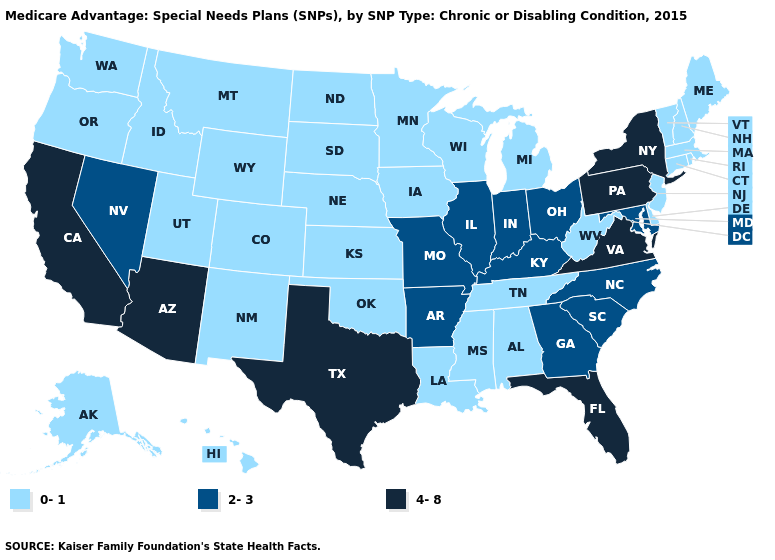What is the highest value in the USA?
Be succinct. 4-8. What is the value of Connecticut?
Keep it brief. 0-1. Name the states that have a value in the range 0-1?
Write a very short answer. Alaska, Alabama, Colorado, Connecticut, Delaware, Hawaii, Iowa, Idaho, Kansas, Louisiana, Massachusetts, Maine, Michigan, Minnesota, Mississippi, Montana, North Dakota, Nebraska, New Hampshire, New Jersey, New Mexico, Oklahoma, Oregon, Rhode Island, South Dakota, Tennessee, Utah, Vermont, Washington, Wisconsin, West Virginia, Wyoming. Name the states that have a value in the range 2-3?
Answer briefly. Arkansas, Georgia, Illinois, Indiana, Kentucky, Maryland, Missouri, North Carolina, Nevada, Ohio, South Carolina. What is the value of Nevada?
Keep it brief. 2-3. What is the value of Nevada?
Concise answer only. 2-3. Does New Hampshire have the highest value in the Northeast?
Give a very brief answer. No. Name the states that have a value in the range 4-8?
Short answer required. Arizona, California, Florida, New York, Pennsylvania, Texas, Virginia. Does Idaho have the same value as Wisconsin?
Keep it brief. Yes. Name the states that have a value in the range 0-1?
Keep it brief. Alaska, Alabama, Colorado, Connecticut, Delaware, Hawaii, Iowa, Idaho, Kansas, Louisiana, Massachusetts, Maine, Michigan, Minnesota, Mississippi, Montana, North Dakota, Nebraska, New Hampshire, New Jersey, New Mexico, Oklahoma, Oregon, Rhode Island, South Dakota, Tennessee, Utah, Vermont, Washington, Wisconsin, West Virginia, Wyoming. Which states hav the highest value in the Northeast?
Concise answer only. New York, Pennsylvania. Does Massachusetts have a lower value than South Carolina?
Answer briefly. Yes. What is the lowest value in the Northeast?
Quick response, please. 0-1. Which states have the highest value in the USA?
Answer briefly. Arizona, California, Florida, New York, Pennsylvania, Texas, Virginia. What is the highest value in the USA?
Quick response, please. 4-8. 